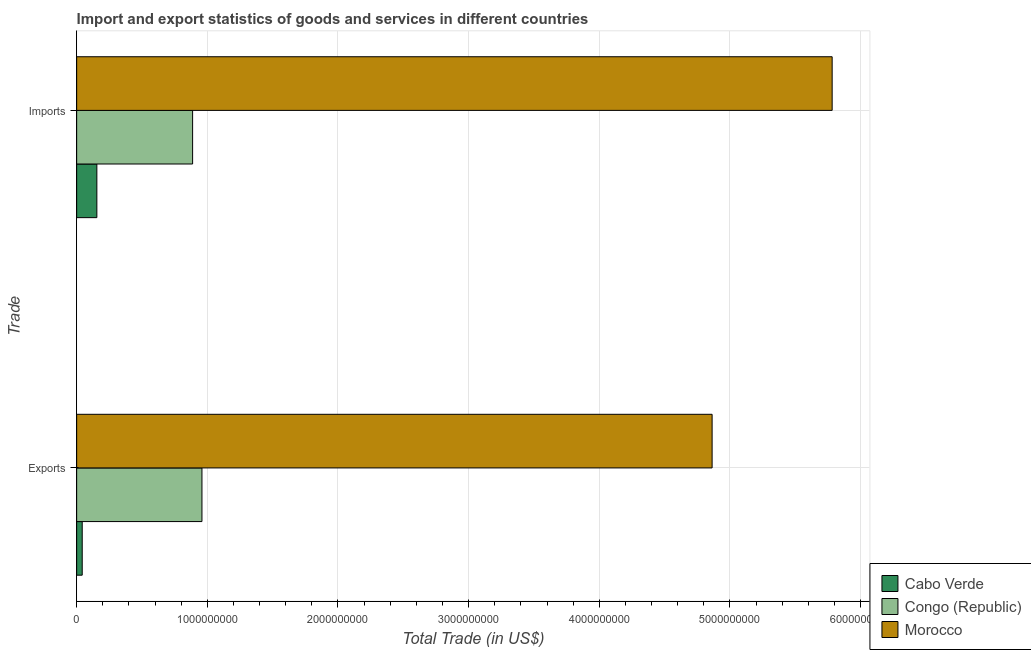How many different coloured bars are there?
Provide a short and direct response. 3. How many groups of bars are there?
Your response must be concise. 2. What is the label of the 1st group of bars from the top?
Offer a terse response. Imports. What is the imports of goods and services in Cabo Verde?
Ensure brevity in your answer.  1.55e+08. Across all countries, what is the maximum imports of goods and services?
Keep it short and to the point. 5.78e+09. Across all countries, what is the minimum export of goods and services?
Make the answer very short. 4.26e+07. In which country was the export of goods and services maximum?
Your answer should be compact. Morocco. In which country was the imports of goods and services minimum?
Ensure brevity in your answer.  Cabo Verde. What is the total export of goods and services in the graph?
Provide a short and direct response. 5.87e+09. What is the difference between the imports of goods and services in Congo (Republic) and that in Cabo Verde?
Your answer should be compact. 7.33e+08. What is the difference between the export of goods and services in Congo (Republic) and the imports of goods and services in Cabo Verde?
Your response must be concise. 8.04e+08. What is the average export of goods and services per country?
Give a very brief answer. 1.96e+09. What is the difference between the imports of goods and services and export of goods and services in Congo (Republic)?
Keep it short and to the point. -7.15e+07. What is the ratio of the imports of goods and services in Morocco to that in Cabo Verde?
Offer a terse response. 37.39. What does the 2nd bar from the top in Exports represents?
Offer a very short reply. Congo (Republic). What does the 2nd bar from the bottom in Exports represents?
Ensure brevity in your answer.  Congo (Republic). How many bars are there?
Make the answer very short. 6. How many countries are there in the graph?
Keep it short and to the point. 3. Are the values on the major ticks of X-axis written in scientific E-notation?
Give a very brief answer. No. Does the graph contain any zero values?
Your answer should be compact. No. Does the graph contain grids?
Keep it short and to the point. Yes. What is the title of the graph?
Give a very brief answer. Import and export statistics of goods and services in different countries. What is the label or title of the X-axis?
Provide a short and direct response. Total Trade (in US$). What is the label or title of the Y-axis?
Give a very brief answer. Trade. What is the Total Trade (in US$) in Cabo Verde in Exports?
Offer a terse response. 4.26e+07. What is the Total Trade (in US$) in Congo (Republic) in Exports?
Give a very brief answer. 9.59e+08. What is the Total Trade (in US$) in Morocco in Exports?
Your answer should be very brief. 4.86e+09. What is the Total Trade (in US$) of Cabo Verde in Imports?
Your answer should be compact. 1.55e+08. What is the Total Trade (in US$) in Congo (Republic) in Imports?
Provide a succinct answer. 8.87e+08. What is the Total Trade (in US$) in Morocco in Imports?
Your answer should be very brief. 5.78e+09. Across all Trade, what is the maximum Total Trade (in US$) in Cabo Verde?
Offer a very short reply. 1.55e+08. Across all Trade, what is the maximum Total Trade (in US$) of Congo (Republic)?
Your answer should be very brief. 9.59e+08. Across all Trade, what is the maximum Total Trade (in US$) of Morocco?
Your response must be concise. 5.78e+09. Across all Trade, what is the minimum Total Trade (in US$) in Cabo Verde?
Make the answer very short. 4.26e+07. Across all Trade, what is the minimum Total Trade (in US$) in Congo (Republic)?
Ensure brevity in your answer.  8.87e+08. Across all Trade, what is the minimum Total Trade (in US$) of Morocco?
Your response must be concise. 4.86e+09. What is the total Total Trade (in US$) in Cabo Verde in the graph?
Provide a short and direct response. 1.97e+08. What is the total Total Trade (in US$) of Congo (Republic) in the graph?
Provide a short and direct response. 1.85e+09. What is the total Total Trade (in US$) in Morocco in the graph?
Ensure brevity in your answer.  1.06e+1. What is the difference between the Total Trade (in US$) of Cabo Verde in Exports and that in Imports?
Make the answer very short. -1.12e+08. What is the difference between the Total Trade (in US$) of Congo (Republic) in Exports and that in Imports?
Provide a succinct answer. 7.15e+07. What is the difference between the Total Trade (in US$) of Morocco in Exports and that in Imports?
Ensure brevity in your answer.  -9.19e+08. What is the difference between the Total Trade (in US$) of Cabo Verde in Exports and the Total Trade (in US$) of Congo (Republic) in Imports?
Your response must be concise. -8.45e+08. What is the difference between the Total Trade (in US$) of Cabo Verde in Exports and the Total Trade (in US$) of Morocco in Imports?
Provide a succinct answer. -5.74e+09. What is the difference between the Total Trade (in US$) of Congo (Republic) in Exports and the Total Trade (in US$) of Morocco in Imports?
Offer a terse response. -4.82e+09. What is the average Total Trade (in US$) of Cabo Verde per Trade?
Give a very brief answer. 9.86e+07. What is the average Total Trade (in US$) in Congo (Republic) per Trade?
Ensure brevity in your answer.  9.23e+08. What is the average Total Trade (in US$) in Morocco per Trade?
Offer a very short reply. 5.32e+09. What is the difference between the Total Trade (in US$) in Cabo Verde and Total Trade (in US$) in Congo (Republic) in Exports?
Provide a short and direct response. -9.16e+08. What is the difference between the Total Trade (in US$) in Cabo Verde and Total Trade (in US$) in Morocco in Exports?
Ensure brevity in your answer.  -4.82e+09. What is the difference between the Total Trade (in US$) in Congo (Republic) and Total Trade (in US$) in Morocco in Exports?
Your answer should be compact. -3.90e+09. What is the difference between the Total Trade (in US$) in Cabo Verde and Total Trade (in US$) in Congo (Republic) in Imports?
Make the answer very short. -7.33e+08. What is the difference between the Total Trade (in US$) in Cabo Verde and Total Trade (in US$) in Morocco in Imports?
Offer a very short reply. -5.63e+09. What is the difference between the Total Trade (in US$) in Congo (Republic) and Total Trade (in US$) in Morocco in Imports?
Ensure brevity in your answer.  -4.89e+09. What is the ratio of the Total Trade (in US$) of Cabo Verde in Exports to that in Imports?
Your answer should be compact. 0.28. What is the ratio of the Total Trade (in US$) in Congo (Republic) in Exports to that in Imports?
Provide a short and direct response. 1.08. What is the ratio of the Total Trade (in US$) of Morocco in Exports to that in Imports?
Offer a very short reply. 0.84. What is the difference between the highest and the second highest Total Trade (in US$) in Cabo Verde?
Keep it short and to the point. 1.12e+08. What is the difference between the highest and the second highest Total Trade (in US$) of Congo (Republic)?
Provide a short and direct response. 7.15e+07. What is the difference between the highest and the second highest Total Trade (in US$) in Morocco?
Keep it short and to the point. 9.19e+08. What is the difference between the highest and the lowest Total Trade (in US$) in Cabo Verde?
Keep it short and to the point. 1.12e+08. What is the difference between the highest and the lowest Total Trade (in US$) in Congo (Republic)?
Keep it short and to the point. 7.15e+07. What is the difference between the highest and the lowest Total Trade (in US$) in Morocco?
Give a very brief answer. 9.19e+08. 